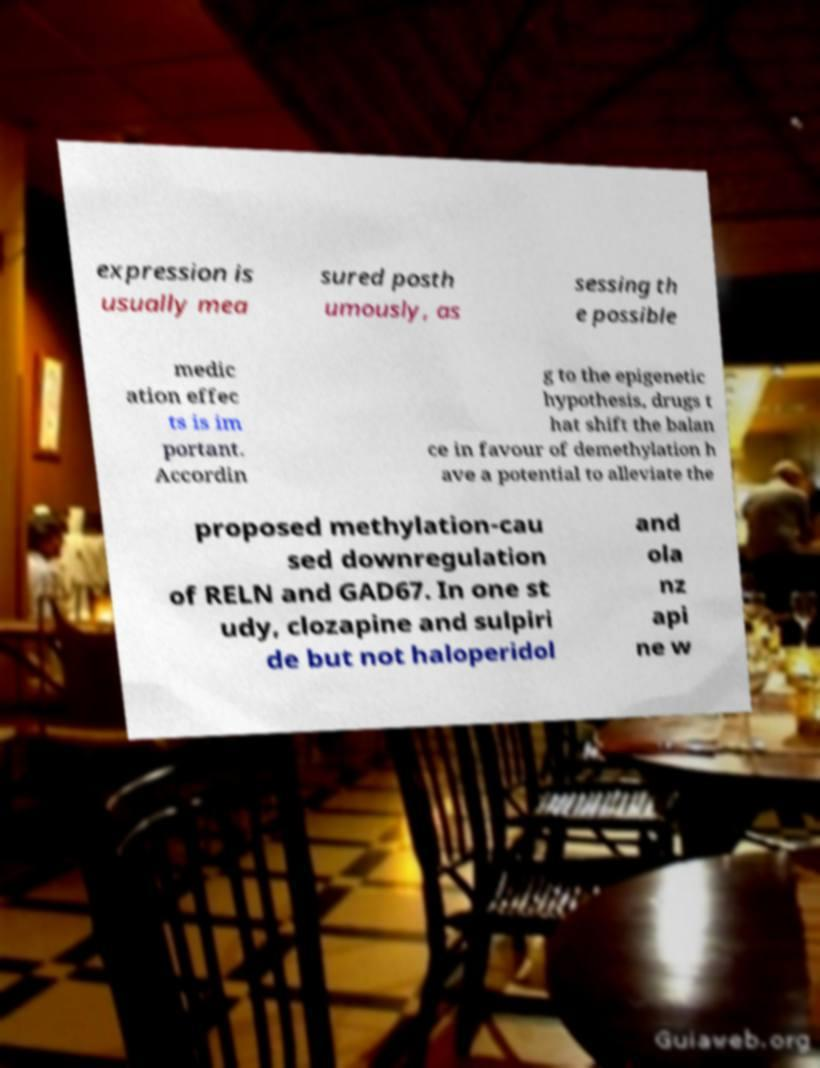I need the written content from this picture converted into text. Can you do that? expression is usually mea sured posth umously, as sessing th e possible medic ation effec ts is im portant. Accordin g to the epigenetic hypothesis, drugs t hat shift the balan ce in favour of demethylation h ave a potential to alleviate the proposed methylation-cau sed downregulation of RELN and GAD67. In one st udy, clozapine and sulpiri de but not haloperidol and ola nz api ne w 